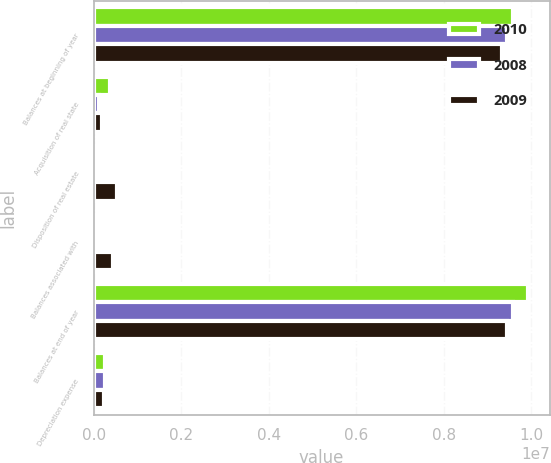Convert chart to OTSL. <chart><loc_0><loc_0><loc_500><loc_500><stacked_bar_chart><ecel><fcel>Balances at beginning of year<fcel>Acquisition of real state<fcel>Disposition of real estate<fcel>Balances associated with<fcel>Balances at end of year<fcel>Depreciation expense<nl><fcel>2010<fcel>9.58616e+06<fcel>377354<fcel>61139<fcel>25531<fcel>9.92791e+06<fcel>261734<nl><fcel>2008<fcel>9.44975e+06<fcel>119221<fcel>60134<fcel>77319<fcel>9.58616e+06<fcel>249350<nl><fcel>2009<fcel>9.34187e+06<fcel>194325<fcel>523687<fcel>438821<fcel>9.44975e+06<fcel>234284<nl></chart> 